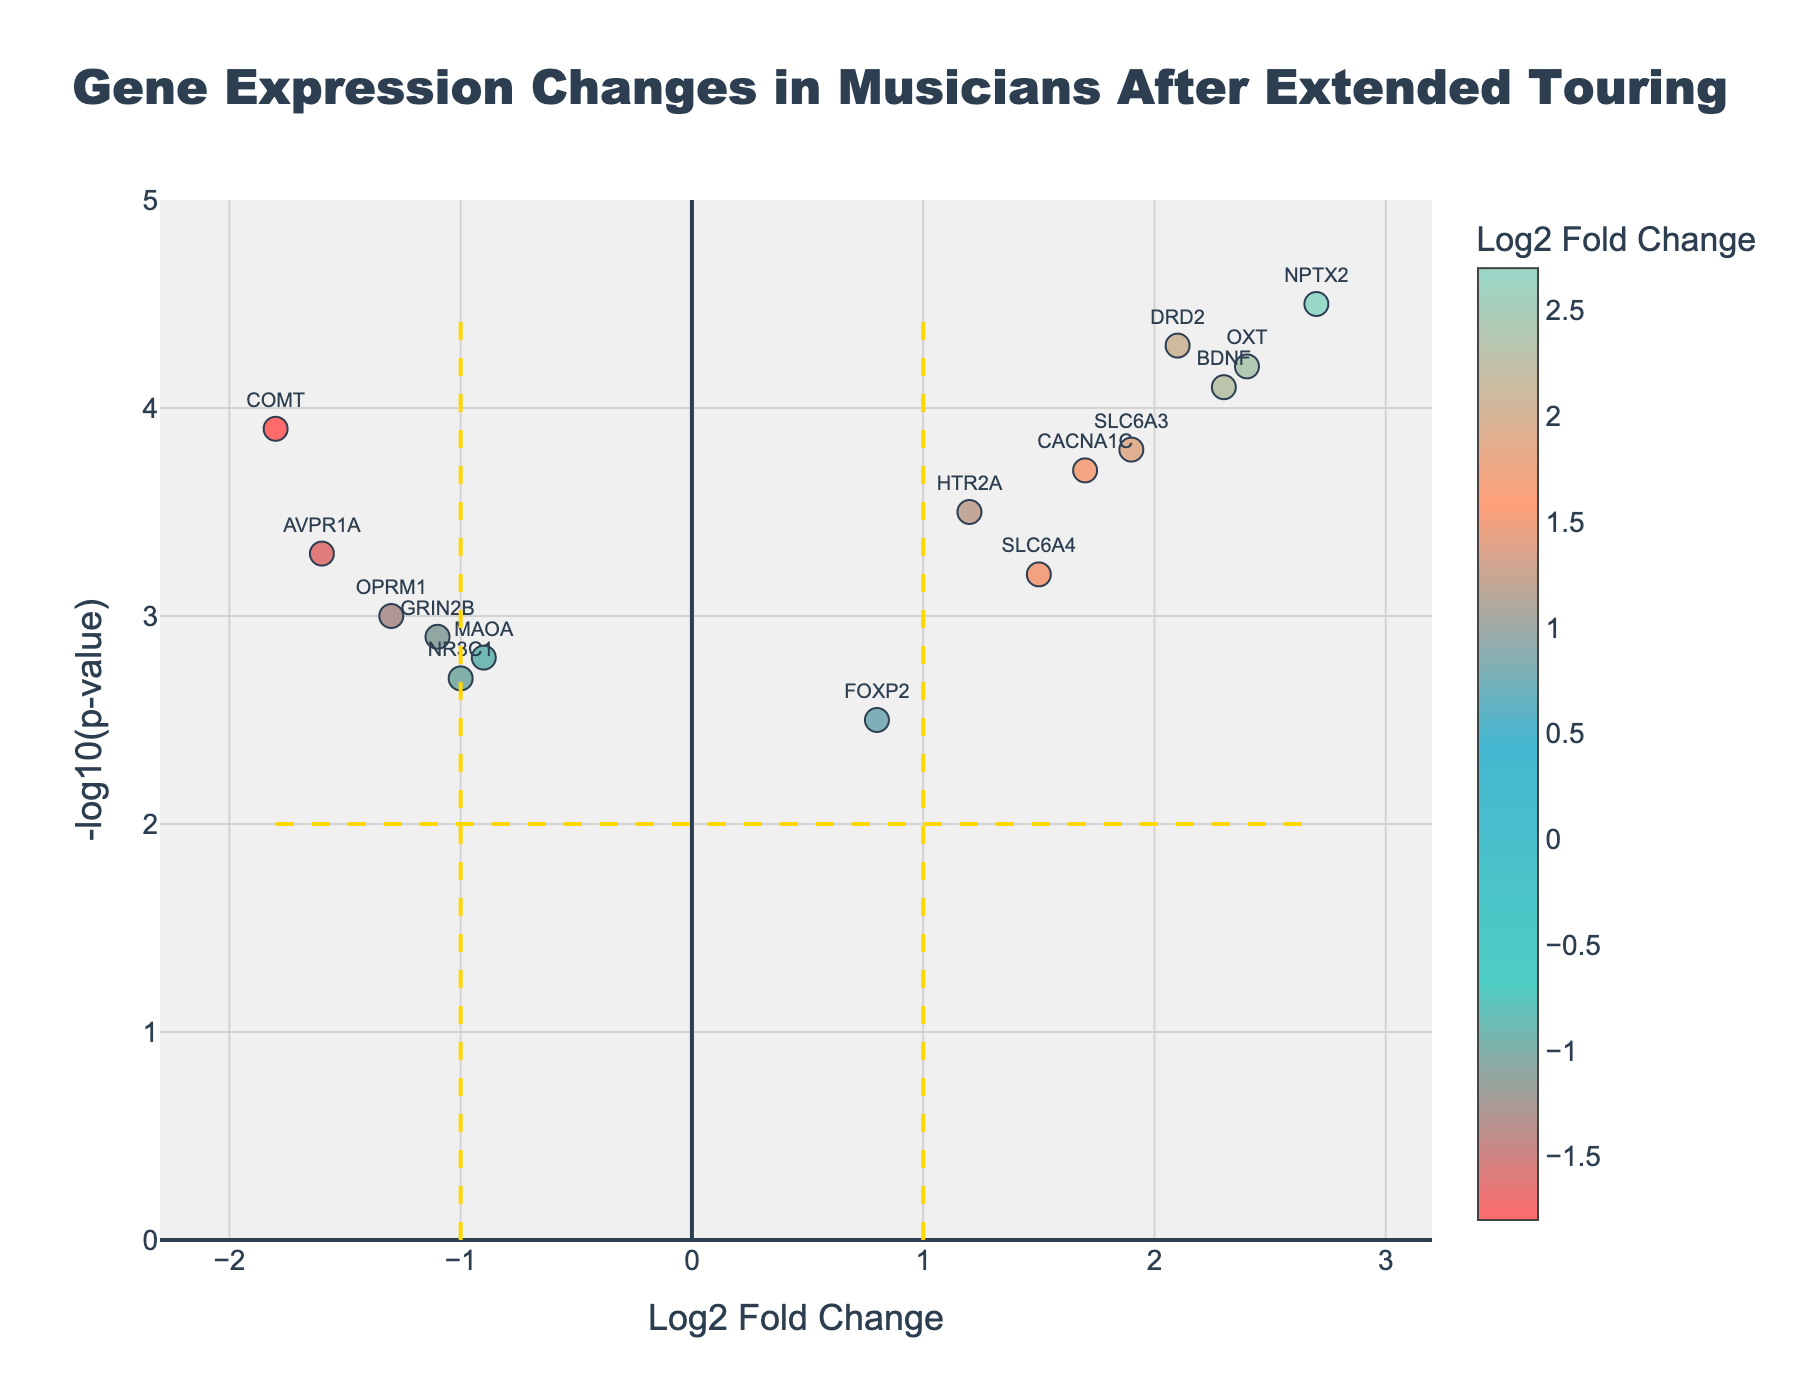What is the title of the figure? The title is prominently displayed at the top center of the figure, usually in a larger font. The title provides a quick summary of what the plot is about. In this case, it is "Gene Expression Changes in Musicians After Extended Touring."
Answer: Gene Expression Changes in Musicians After Extended Touring What's the Log2 Fold Change of gene BDNF? The gene names are labeled on the plot, and each gene's Log2 Fold Change is on the x-axis. Specifically, for BDNF, check where its label is located on the x-axis. The value of BDNF is 2.3.
Answer: 2.3 Which gene has the highest -log10(p-value)? Check the y-axis for -log10(p-value) values and identify the gene label positioned at the highest point. The gene label found at the highest point of the y-axis is NPTX2.
Answer: NPTX2 How many genes have a Log2 Fold Change greater than 1? Identify and count all the points to the right of the vertical line at x=1. These are the genes with a Log2 Fold Change greater than 1. There are 7 such genes: BDNF, SLC6A4, HTR2A, DRD2, NPTX2, CACNA1C, and OXT.
Answer: 7 Which genes have both a Log2 Fold Change greater than 1 and a -log10(p-value) greater than 3? Look for points that are both to the right of the vertical line at x=1 and above the horizontal line at y=3. There are 6 genes: BDNF, SLC6A4, DRD2, NPTX2, CACNA1C, and OXT.
Answer: 6 Is the gene SLC6A3 upregulated or downregulated? Determine if the gene is positioned to the right or left of the vertical line at x=0. If it's to the right, it's upregulated (positive Log2 Fold Change); if to the left, downregulated (negative Log2 Fold Change). SLC6A3 is to the right, indicating it is upregulated.
Answer: Upregulated Which gene has the largest change in Log2 Fold Change? Find the gene with the most extreme value on the x-axis, either positive or negative. The gene with the largest change is NPTX2, with a Log2 Fold Change of 2.7.
Answer: NPTX2 How many genes have a -log10(p-value) less than 2.5? Identify and count all points below the horizontal line at y=2.5. There are 2 genes: FOXP2 and NR3C1.
Answer: 2 In terms of gene expression changes, which is more upregulated, BDNF or CACNA1C? Compare the positions of BDNF and CACNA1C on the x-axis. The gene farther to the right has a higher Log2 Fold Change. BDNF (2.3) is more upregulated than CACNA1C (1.7).
Answer: BDNF Which of the following genes: MAOA, FOXP2, and AVPR1A, has the smallest -log10(p-value)? Compare the y-axis values of MAOA, FOXP2, and AVPR1A. The gene with the lowest value is FOXP2 (2.5).
Answer: FOXP2 